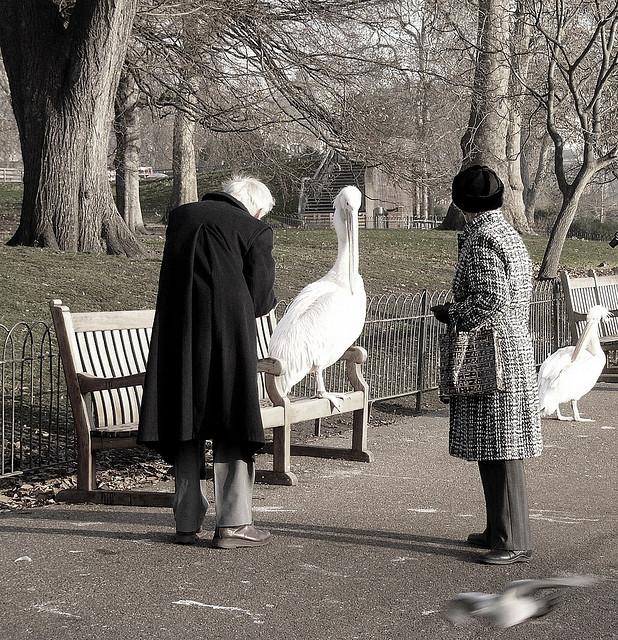What kind of birds are these?
Give a very brief answer. Pelican. What colors can be seen in this picture?
Give a very brief answer. Black and white. What is the bird in the center standing on?
Short answer required. Bench. How many animals are in this photo?
Write a very short answer. 2. 